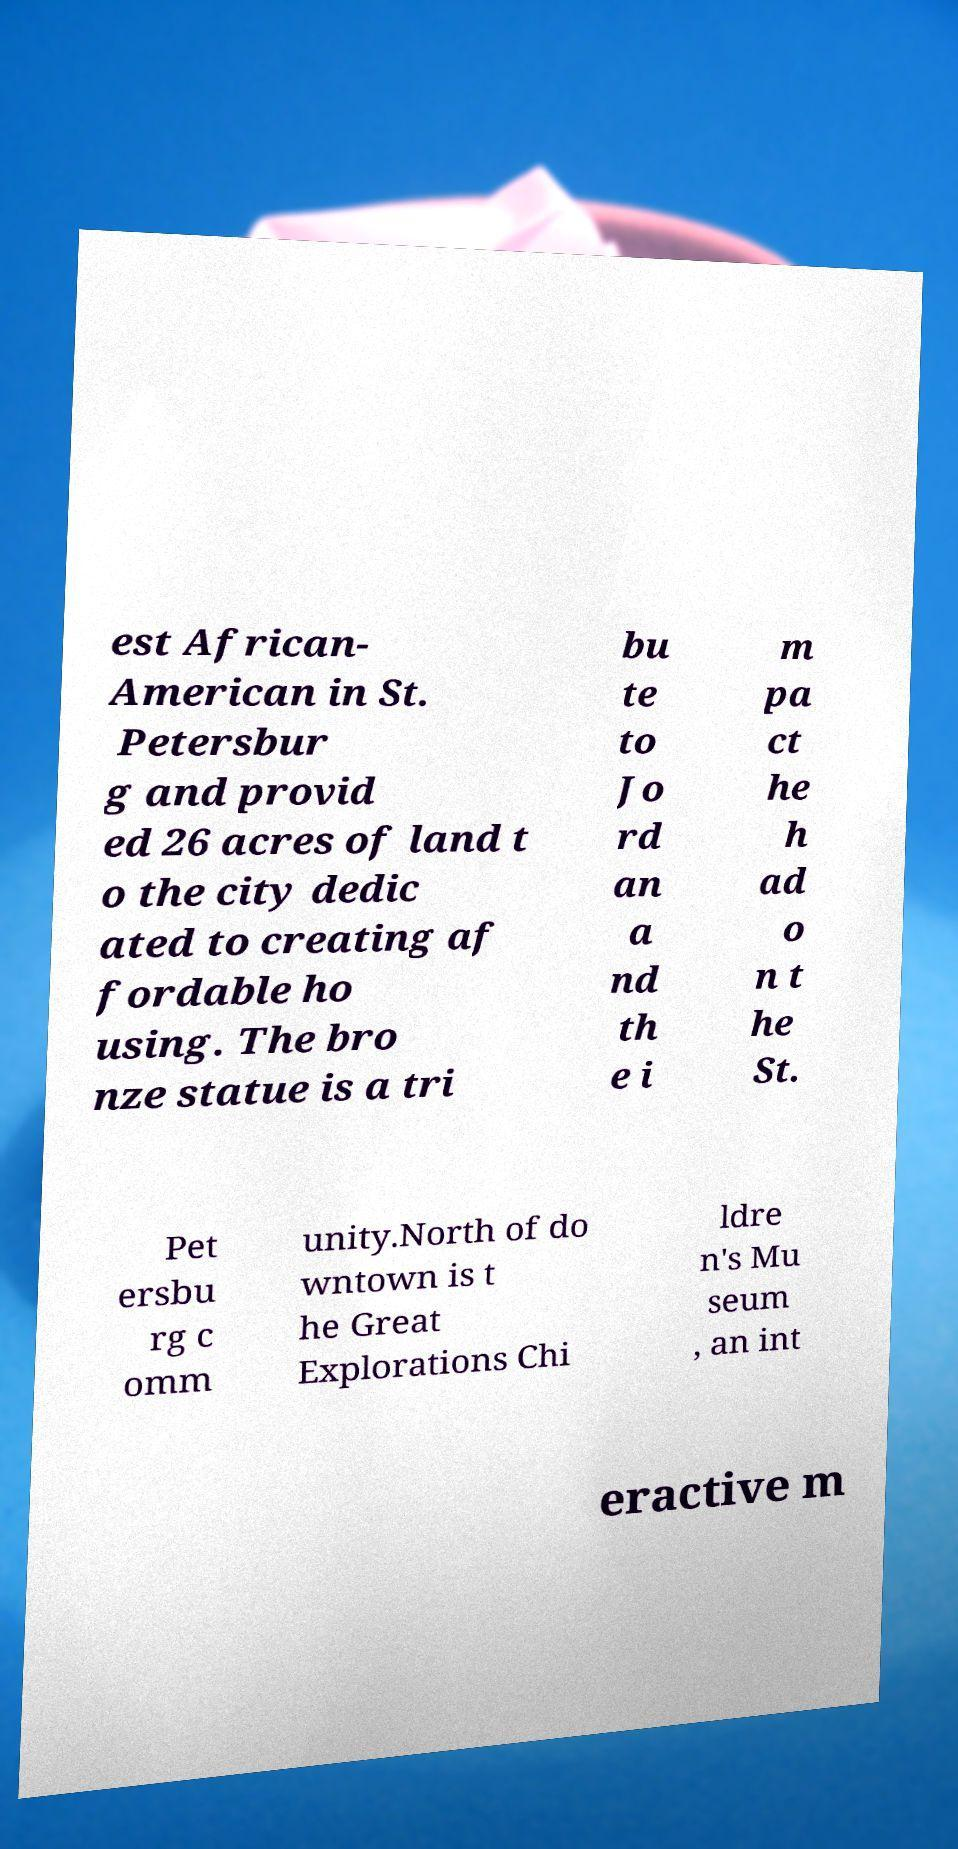Please read and relay the text visible in this image. What does it say? est African- American in St. Petersbur g and provid ed 26 acres of land t o the city dedic ated to creating af fordable ho using. The bro nze statue is a tri bu te to Jo rd an a nd th e i m pa ct he h ad o n t he St. Pet ersbu rg c omm unity.North of do wntown is t he Great Explorations Chi ldre n's Mu seum , an int eractive m 